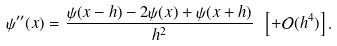Convert formula to latex. <formula><loc_0><loc_0><loc_500><loc_500>\psi ^ { \prime \prime } ( x ) = \frac { \psi ( x - h ) - 2 \psi ( x ) + \psi ( x + h ) } { h ^ { 2 } } \ \left [ + \mathcal { O } ( h ^ { 4 } ) \right ] .</formula> 